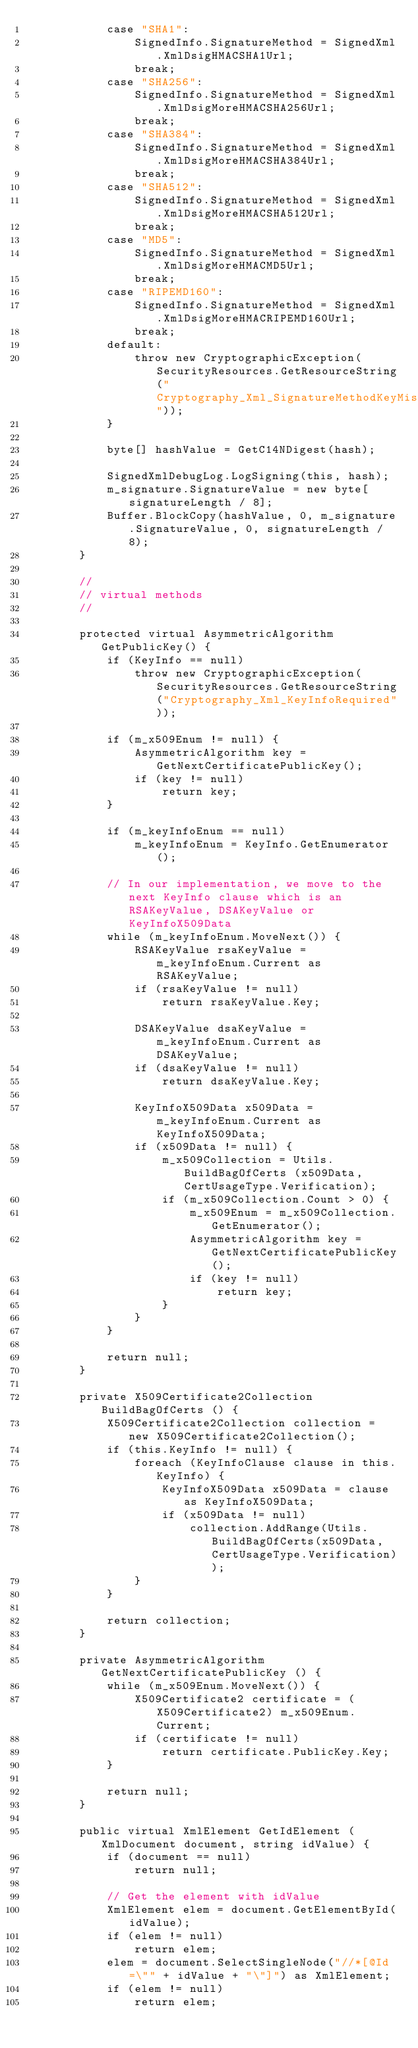Convert code to text. <code><loc_0><loc_0><loc_500><loc_500><_C#_>            case "SHA1":
                SignedInfo.SignatureMethod = SignedXml.XmlDsigHMACSHA1Url;
                break;
            case "SHA256":
                SignedInfo.SignatureMethod = SignedXml.XmlDsigMoreHMACSHA256Url;
                break;
            case "SHA384":
                SignedInfo.SignatureMethod = SignedXml.XmlDsigMoreHMACSHA384Url;
                break;
            case "SHA512":
                SignedInfo.SignatureMethod = SignedXml.XmlDsigMoreHMACSHA512Url;
                break;
            case "MD5":
                SignedInfo.SignatureMethod = SignedXml.XmlDsigMoreHMACMD5Url;
                break;
            case "RIPEMD160":
                SignedInfo.SignatureMethod = SignedXml.XmlDsigMoreHMACRIPEMD160Url;
                break;
            default:
                throw new CryptographicException(SecurityResources.GetResourceString("Cryptography_Xml_SignatureMethodKeyMismatch"));
            }

            byte[] hashValue = GetC14NDigest(hash);

            SignedXmlDebugLog.LogSigning(this, hash);
            m_signature.SignatureValue = new byte[signatureLength / 8];
            Buffer.BlockCopy(hashValue, 0, m_signature.SignatureValue, 0, signatureLength / 8);
        }

        //
        // virtual methods
        //

        protected virtual AsymmetricAlgorithm GetPublicKey() {
            if (KeyInfo == null)
                throw new CryptographicException(SecurityResources.GetResourceString("Cryptography_Xml_KeyInfoRequired"));

            if (m_x509Enum != null) {
                AsymmetricAlgorithm key = GetNextCertificatePublicKey();
                if (key != null)
                    return key;
            }

            if (m_keyInfoEnum == null)
                m_keyInfoEnum = KeyInfo.GetEnumerator();

            // In our implementation, we move to the next KeyInfo clause which is an RSAKeyValue, DSAKeyValue or KeyInfoX509Data
            while (m_keyInfoEnum.MoveNext()) {
                RSAKeyValue rsaKeyValue = m_keyInfoEnum.Current as RSAKeyValue;
                if (rsaKeyValue != null) 
                    return rsaKeyValue.Key;

                DSAKeyValue dsaKeyValue = m_keyInfoEnum.Current as DSAKeyValue;
                if (dsaKeyValue != null) 
                    return dsaKeyValue.Key;

                KeyInfoX509Data x509Data = m_keyInfoEnum.Current as KeyInfoX509Data;
                if (x509Data != null) {
                    m_x509Collection = Utils.BuildBagOfCerts (x509Data, CertUsageType.Verification);
                    if (m_x509Collection.Count > 0) {
                        m_x509Enum = m_x509Collection.GetEnumerator();
                        AsymmetricAlgorithm key = GetNextCertificatePublicKey();
                        if (key != null)
                            return key;
                    }
                }
            }

            return null;
        }

        private X509Certificate2Collection BuildBagOfCerts () {
            X509Certificate2Collection collection = new X509Certificate2Collection();
            if (this.KeyInfo != null) {
                foreach (KeyInfoClause clause in this.KeyInfo) {
                    KeyInfoX509Data x509Data = clause as KeyInfoX509Data;
                    if (x509Data != null) 
                        collection.AddRange(Utils.BuildBagOfCerts(x509Data, CertUsageType.Verification));
                }
            }

            return collection;
        }

        private AsymmetricAlgorithm GetNextCertificatePublicKey () {
            while (m_x509Enum.MoveNext()) {
                X509Certificate2 certificate = (X509Certificate2) m_x509Enum.Current;
                if (certificate != null)
                    return certificate.PublicKey.Key;
            }

            return null;
        }

        public virtual XmlElement GetIdElement (XmlDocument document, string idValue) {
            if (document == null)
                return null;

            // Get the element with idValue
            XmlElement elem = document.GetElementById(idValue);
            if (elem != null)
                return elem;
            elem = document.SelectSingleNode("//*[@Id=\"" + idValue + "\"]") as XmlElement;
            if (elem != null)
                return elem;</code> 